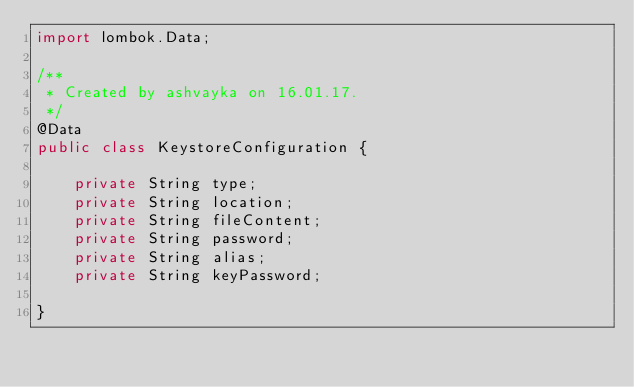<code> <loc_0><loc_0><loc_500><loc_500><_Java_>import lombok.Data;

/**
 * Created by ashvayka on 16.01.17.
 */
@Data
public class KeystoreConfiguration {

    private String type;
    private String location;
    private String fileContent;
    private String password;
    private String alias;
    private String keyPassword;

}
</code> 